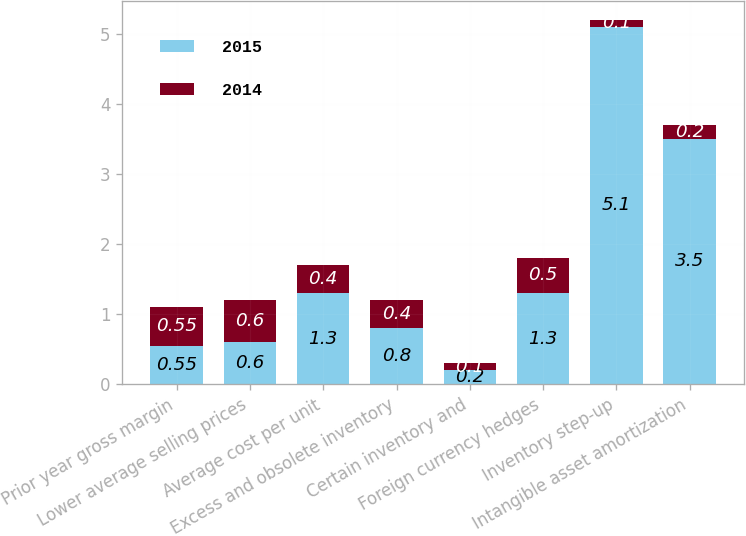Convert chart to OTSL. <chart><loc_0><loc_0><loc_500><loc_500><stacked_bar_chart><ecel><fcel>Prior year gross margin<fcel>Lower average selling prices<fcel>Average cost per unit<fcel>Excess and obsolete inventory<fcel>Certain inventory and<fcel>Foreign currency hedges<fcel>Inventory step-up<fcel>Intangible asset amortization<nl><fcel>2015<fcel>0.55<fcel>0.6<fcel>1.3<fcel>0.8<fcel>0.2<fcel>1.3<fcel>5.1<fcel>3.5<nl><fcel>2014<fcel>0.55<fcel>0.6<fcel>0.4<fcel>0.4<fcel>0.1<fcel>0.5<fcel>0.1<fcel>0.2<nl></chart> 